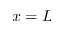<formula> <loc_0><loc_0><loc_500><loc_500>x = L</formula> 